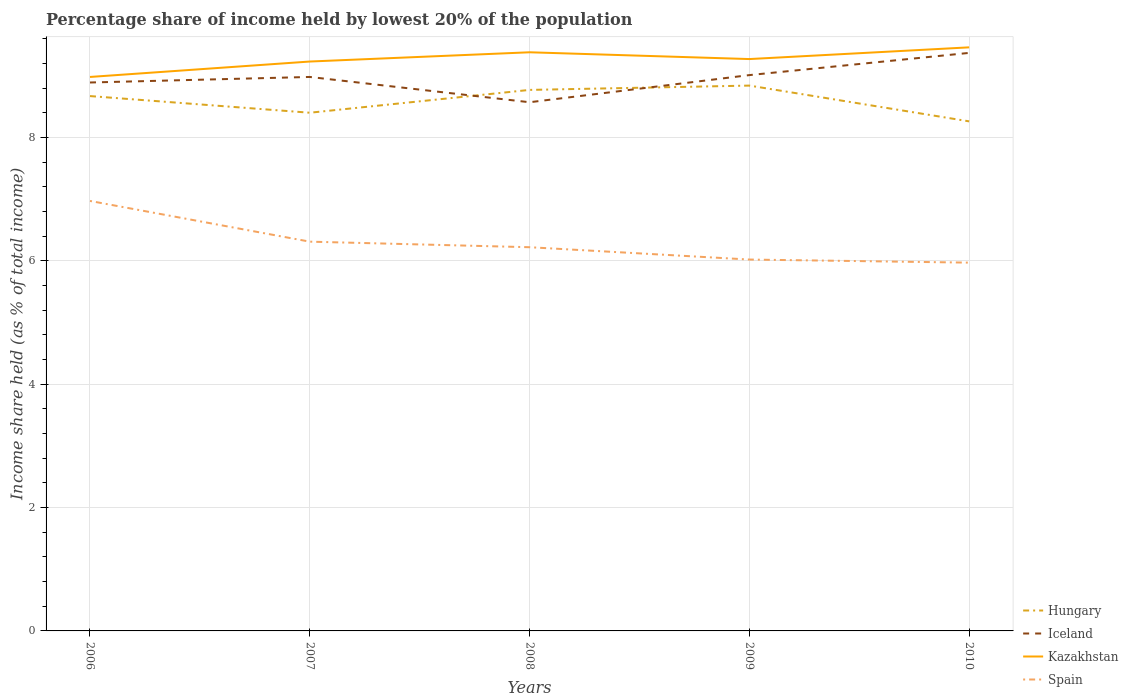Does the line corresponding to Iceland intersect with the line corresponding to Kazakhstan?
Keep it short and to the point. No. Is the number of lines equal to the number of legend labels?
Offer a very short reply. Yes. Across all years, what is the maximum percentage share of income held by lowest 20% of the population in Iceland?
Your answer should be compact. 8.57. What is the total percentage share of income held by lowest 20% of the population in Spain in the graph?
Make the answer very short. 0.66. What is the difference between the highest and the second highest percentage share of income held by lowest 20% of the population in Hungary?
Offer a very short reply. 0.58. What is the difference between the highest and the lowest percentage share of income held by lowest 20% of the population in Iceland?
Offer a terse response. 3. How many lines are there?
Make the answer very short. 4. How many years are there in the graph?
Your response must be concise. 5. Are the values on the major ticks of Y-axis written in scientific E-notation?
Ensure brevity in your answer.  No. Does the graph contain any zero values?
Ensure brevity in your answer.  No. Does the graph contain grids?
Your answer should be compact. Yes. How many legend labels are there?
Ensure brevity in your answer.  4. What is the title of the graph?
Give a very brief answer. Percentage share of income held by lowest 20% of the population. Does "Azerbaijan" appear as one of the legend labels in the graph?
Your answer should be compact. No. What is the label or title of the X-axis?
Your response must be concise. Years. What is the label or title of the Y-axis?
Offer a very short reply. Income share held (as % of total income). What is the Income share held (as % of total income) in Hungary in 2006?
Offer a very short reply. 8.67. What is the Income share held (as % of total income) of Iceland in 2006?
Ensure brevity in your answer.  8.89. What is the Income share held (as % of total income) in Kazakhstan in 2006?
Your response must be concise. 8.98. What is the Income share held (as % of total income) of Spain in 2006?
Offer a very short reply. 6.97. What is the Income share held (as % of total income) of Hungary in 2007?
Make the answer very short. 8.4. What is the Income share held (as % of total income) of Iceland in 2007?
Your answer should be compact. 8.98. What is the Income share held (as % of total income) in Kazakhstan in 2007?
Your response must be concise. 9.23. What is the Income share held (as % of total income) of Spain in 2007?
Give a very brief answer. 6.31. What is the Income share held (as % of total income) of Hungary in 2008?
Offer a very short reply. 8.77. What is the Income share held (as % of total income) of Iceland in 2008?
Offer a very short reply. 8.57. What is the Income share held (as % of total income) in Kazakhstan in 2008?
Your response must be concise. 9.38. What is the Income share held (as % of total income) in Spain in 2008?
Keep it short and to the point. 6.22. What is the Income share held (as % of total income) of Hungary in 2009?
Keep it short and to the point. 8.84. What is the Income share held (as % of total income) in Iceland in 2009?
Your answer should be very brief. 9.01. What is the Income share held (as % of total income) in Kazakhstan in 2009?
Keep it short and to the point. 9.27. What is the Income share held (as % of total income) of Spain in 2009?
Provide a short and direct response. 6.02. What is the Income share held (as % of total income) of Hungary in 2010?
Give a very brief answer. 8.26. What is the Income share held (as % of total income) of Iceland in 2010?
Offer a terse response. 9.37. What is the Income share held (as % of total income) in Kazakhstan in 2010?
Ensure brevity in your answer.  9.46. What is the Income share held (as % of total income) of Spain in 2010?
Provide a succinct answer. 5.97. Across all years, what is the maximum Income share held (as % of total income) in Hungary?
Offer a very short reply. 8.84. Across all years, what is the maximum Income share held (as % of total income) of Iceland?
Your answer should be very brief. 9.37. Across all years, what is the maximum Income share held (as % of total income) in Kazakhstan?
Make the answer very short. 9.46. Across all years, what is the maximum Income share held (as % of total income) in Spain?
Offer a very short reply. 6.97. Across all years, what is the minimum Income share held (as % of total income) in Hungary?
Ensure brevity in your answer.  8.26. Across all years, what is the minimum Income share held (as % of total income) in Iceland?
Your answer should be compact. 8.57. Across all years, what is the minimum Income share held (as % of total income) of Kazakhstan?
Provide a short and direct response. 8.98. Across all years, what is the minimum Income share held (as % of total income) in Spain?
Provide a succinct answer. 5.97. What is the total Income share held (as % of total income) of Hungary in the graph?
Make the answer very short. 42.94. What is the total Income share held (as % of total income) of Iceland in the graph?
Ensure brevity in your answer.  44.82. What is the total Income share held (as % of total income) of Kazakhstan in the graph?
Your answer should be very brief. 46.32. What is the total Income share held (as % of total income) in Spain in the graph?
Keep it short and to the point. 31.49. What is the difference between the Income share held (as % of total income) of Hungary in 2006 and that in 2007?
Make the answer very short. 0.27. What is the difference between the Income share held (as % of total income) in Iceland in 2006 and that in 2007?
Make the answer very short. -0.09. What is the difference between the Income share held (as % of total income) of Spain in 2006 and that in 2007?
Your response must be concise. 0.66. What is the difference between the Income share held (as % of total income) in Iceland in 2006 and that in 2008?
Your response must be concise. 0.32. What is the difference between the Income share held (as % of total income) of Kazakhstan in 2006 and that in 2008?
Offer a terse response. -0.4. What is the difference between the Income share held (as % of total income) of Hungary in 2006 and that in 2009?
Give a very brief answer. -0.17. What is the difference between the Income share held (as % of total income) of Iceland in 2006 and that in 2009?
Provide a succinct answer. -0.12. What is the difference between the Income share held (as % of total income) in Kazakhstan in 2006 and that in 2009?
Keep it short and to the point. -0.29. What is the difference between the Income share held (as % of total income) in Hungary in 2006 and that in 2010?
Keep it short and to the point. 0.41. What is the difference between the Income share held (as % of total income) of Iceland in 2006 and that in 2010?
Your answer should be very brief. -0.48. What is the difference between the Income share held (as % of total income) of Kazakhstan in 2006 and that in 2010?
Your response must be concise. -0.48. What is the difference between the Income share held (as % of total income) of Spain in 2006 and that in 2010?
Make the answer very short. 1. What is the difference between the Income share held (as % of total income) in Hungary in 2007 and that in 2008?
Your response must be concise. -0.37. What is the difference between the Income share held (as % of total income) of Iceland in 2007 and that in 2008?
Your response must be concise. 0.41. What is the difference between the Income share held (as % of total income) in Spain in 2007 and that in 2008?
Your answer should be very brief. 0.09. What is the difference between the Income share held (as % of total income) of Hungary in 2007 and that in 2009?
Keep it short and to the point. -0.44. What is the difference between the Income share held (as % of total income) of Iceland in 2007 and that in 2009?
Your answer should be very brief. -0.03. What is the difference between the Income share held (as % of total income) of Kazakhstan in 2007 and that in 2009?
Your answer should be compact. -0.04. What is the difference between the Income share held (as % of total income) in Spain in 2007 and that in 2009?
Provide a short and direct response. 0.29. What is the difference between the Income share held (as % of total income) of Hungary in 2007 and that in 2010?
Your response must be concise. 0.14. What is the difference between the Income share held (as % of total income) in Iceland in 2007 and that in 2010?
Provide a succinct answer. -0.39. What is the difference between the Income share held (as % of total income) in Kazakhstan in 2007 and that in 2010?
Your response must be concise. -0.23. What is the difference between the Income share held (as % of total income) in Spain in 2007 and that in 2010?
Offer a very short reply. 0.34. What is the difference between the Income share held (as % of total income) in Hungary in 2008 and that in 2009?
Make the answer very short. -0.07. What is the difference between the Income share held (as % of total income) in Iceland in 2008 and that in 2009?
Your answer should be compact. -0.44. What is the difference between the Income share held (as % of total income) in Kazakhstan in 2008 and that in 2009?
Offer a very short reply. 0.11. What is the difference between the Income share held (as % of total income) of Hungary in 2008 and that in 2010?
Your answer should be very brief. 0.51. What is the difference between the Income share held (as % of total income) in Iceland in 2008 and that in 2010?
Provide a short and direct response. -0.8. What is the difference between the Income share held (as % of total income) of Kazakhstan in 2008 and that in 2010?
Keep it short and to the point. -0.08. What is the difference between the Income share held (as % of total income) in Hungary in 2009 and that in 2010?
Make the answer very short. 0.58. What is the difference between the Income share held (as % of total income) in Iceland in 2009 and that in 2010?
Offer a very short reply. -0.36. What is the difference between the Income share held (as % of total income) in Kazakhstan in 2009 and that in 2010?
Your answer should be compact. -0.19. What is the difference between the Income share held (as % of total income) of Hungary in 2006 and the Income share held (as % of total income) of Iceland in 2007?
Provide a succinct answer. -0.31. What is the difference between the Income share held (as % of total income) of Hungary in 2006 and the Income share held (as % of total income) of Kazakhstan in 2007?
Your answer should be compact. -0.56. What is the difference between the Income share held (as % of total income) in Hungary in 2006 and the Income share held (as % of total income) in Spain in 2007?
Offer a terse response. 2.36. What is the difference between the Income share held (as % of total income) in Iceland in 2006 and the Income share held (as % of total income) in Kazakhstan in 2007?
Keep it short and to the point. -0.34. What is the difference between the Income share held (as % of total income) of Iceland in 2006 and the Income share held (as % of total income) of Spain in 2007?
Your answer should be compact. 2.58. What is the difference between the Income share held (as % of total income) of Kazakhstan in 2006 and the Income share held (as % of total income) of Spain in 2007?
Ensure brevity in your answer.  2.67. What is the difference between the Income share held (as % of total income) of Hungary in 2006 and the Income share held (as % of total income) of Iceland in 2008?
Your answer should be very brief. 0.1. What is the difference between the Income share held (as % of total income) of Hungary in 2006 and the Income share held (as % of total income) of Kazakhstan in 2008?
Your answer should be very brief. -0.71. What is the difference between the Income share held (as % of total income) of Hungary in 2006 and the Income share held (as % of total income) of Spain in 2008?
Offer a very short reply. 2.45. What is the difference between the Income share held (as % of total income) of Iceland in 2006 and the Income share held (as % of total income) of Kazakhstan in 2008?
Offer a very short reply. -0.49. What is the difference between the Income share held (as % of total income) of Iceland in 2006 and the Income share held (as % of total income) of Spain in 2008?
Your response must be concise. 2.67. What is the difference between the Income share held (as % of total income) of Kazakhstan in 2006 and the Income share held (as % of total income) of Spain in 2008?
Give a very brief answer. 2.76. What is the difference between the Income share held (as % of total income) of Hungary in 2006 and the Income share held (as % of total income) of Iceland in 2009?
Provide a succinct answer. -0.34. What is the difference between the Income share held (as % of total income) in Hungary in 2006 and the Income share held (as % of total income) in Kazakhstan in 2009?
Your answer should be compact. -0.6. What is the difference between the Income share held (as % of total income) of Hungary in 2006 and the Income share held (as % of total income) of Spain in 2009?
Provide a short and direct response. 2.65. What is the difference between the Income share held (as % of total income) of Iceland in 2006 and the Income share held (as % of total income) of Kazakhstan in 2009?
Provide a succinct answer. -0.38. What is the difference between the Income share held (as % of total income) in Iceland in 2006 and the Income share held (as % of total income) in Spain in 2009?
Your answer should be very brief. 2.87. What is the difference between the Income share held (as % of total income) of Kazakhstan in 2006 and the Income share held (as % of total income) of Spain in 2009?
Keep it short and to the point. 2.96. What is the difference between the Income share held (as % of total income) of Hungary in 2006 and the Income share held (as % of total income) of Kazakhstan in 2010?
Your answer should be very brief. -0.79. What is the difference between the Income share held (as % of total income) of Hungary in 2006 and the Income share held (as % of total income) of Spain in 2010?
Offer a very short reply. 2.7. What is the difference between the Income share held (as % of total income) of Iceland in 2006 and the Income share held (as % of total income) of Kazakhstan in 2010?
Make the answer very short. -0.57. What is the difference between the Income share held (as % of total income) of Iceland in 2006 and the Income share held (as % of total income) of Spain in 2010?
Offer a very short reply. 2.92. What is the difference between the Income share held (as % of total income) in Kazakhstan in 2006 and the Income share held (as % of total income) in Spain in 2010?
Ensure brevity in your answer.  3.01. What is the difference between the Income share held (as % of total income) of Hungary in 2007 and the Income share held (as % of total income) of Iceland in 2008?
Give a very brief answer. -0.17. What is the difference between the Income share held (as % of total income) in Hungary in 2007 and the Income share held (as % of total income) in Kazakhstan in 2008?
Your response must be concise. -0.98. What is the difference between the Income share held (as % of total income) in Hungary in 2007 and the Income share held (as % of total income) in Spain in 2008?
Offer a terse response. 2.18. What is the difference between the Income share held (as % of total income) of Iceland in 2007 and the Income share held (as % of total income) of Spain in 2008?
Your answer should be very brief. 2.76. What is the difference between the Income share held (as % of total income) in Kazakhstan in 2007 and the Income share held (as % of total income) in Spain in 2008?
Your answer should be very brief. 3.01. What is the difference between the Income share held (as % of total income) in Hungary in 2007 and the Income share held (as % of total income) in Iceland in 2009?
Keep it short and to the point. -0.61. What is the difference between the Income share held (as % of total income) of Hungary in 2007 and the Income share held (as % of total income) of Kazakhstan in 2009?
Offer a terse response. -0.87. What is the difference between the Income share held (as % of total income) of Hungary in 2007 and the Income share held (as % of total income) of Spain in 2009?
Ensure brevity in your answer.  2.38. What is the difference between the Income share held (as % of total income) of Iceland in 2007 and the Income share held (as % of total income) of Kazakhstan in 2009?
Ensure brevity in your answer.  -0.29. What is the difference between the Income share held (as % of total income) of Iceland in 2007 and the Income share held (as % of total income) of Spain in 2009?
Your answer should be very brief. 2.96. What is the difference between the Income share held (as % of total income) of Kazakhstan in 2007 and the Income share held (as % of total income) of Spain in 2009?
Your response must be concise. 3.21. What is the difference between the Income share held (as % of total income) of Hungary in 2007 and the Income share held (as % of total income) of Iceland in 2010?
Your response must be concise. -0.97. What is the difference between the Income share held (as % of total income) of Hungary in 2007 and the Income share held (as % of total income) of Kazakhstan in 2010?
Your answer should be compact. -1.06. What is the difference between the Income share held (as % of total income) of Hungary in 2007 and the Income share held (as % of total income) of Spain in 2010?
Give a very brief answer. 2.43. What is the difference between the Income share held (as % of total income) in Iceland in 2007 and the Income share held (as % of total income) in Kazakhstan in 2010?
Your response must be concise. -0.48. What is the difference between the Income share held (as % of total income) of Iceland in 2007 and the Income share held (as % of total income) of Spain in 2010?
Give a very brief answer. 3.01. What is the difference between the Income share held (as % of total income) in Kazakhstan in 2007 and the Income share held (as % of total income) in Spain in 2010?
Make the answer very short. 3.26. What is the difference between the Income share held (as % of total income) of Hungary in 2008 and the Income share held (as % of total income) of Iceland in 2009?
Offer a terse response. -0.24. What is the difference between the Income share held (as % of total income) in Hungary in 2008 and the Income share held (as % of total income) in Spain in 2009?
Give a very brief answer. 2.75. What is the difference between the Income share held (as % of total income) of Iceland in 2008 and the Income share held (as % of total income) of Spain in 2009?
Offer a very short reply. 2.55. What is the difference between the Income share held (as % of total income) in Kazakhstan in 2008 and the Income share held (as % of total income) in Spain in 2009?
Your answer should be very brief. 3.36. What is the difference between the Income share held (as % of total income) of Hungary in 2008 and the Income share held (as % of total income) of Iceland in 2010?
Make the answer very short. -0.6. What is the difference between the Income share held (as % of total income) of Hungary in 2008 and the Income share held (as % of total income) of Kazakhstan in 2010?
Give a very brief answer. -0.69. What is the difference between the Income share held (as % of total income) in Hungary in 2008 and the Income share held (as % of total income) in Spain in 2010?
Ensure brevity in your answer.  2.8. What is the difference between the Income share held (as % of total income) in Iceland in 2008 and the Income share held (as % of total income) in Kazakhstan in 2010?
Offer a terse response. -0.89. What is the difference between the Income share held (as % of total income) of Kazakhstan in 2008 and the Income share held (as % of total income) of Spain in 2010?
Ensure brevity in your answer.  3.41. What is the difference between the Income share held (as % of total income) of Hungary in 2009 and the Income share held (as % of total income) of Iceland in 2010?
Keep it short and to the point. -0.53. What is the difference between the Income share held (as % of total income) of Hungary in 2009 and the Income share held (as % of total income) of Kazakhstan in 2010?
Keep it short and to the point. -0.62. What is the difference between the Income share held (as % of total income) of Hungary in 2009 and the Income share held (as % of total income) of Spain in 2010?
Your response must be concise. 2.87. What is the difference between the Income share held (as % of total income) in Iceland in 2009 and the Income share held (as % of total income) in Kazakhstan in 2010?
Provide a short and direct response. -0.45. What is the difference between the Income share held (as % of total income) in Iceland in 2009 and the Income share held (as % of total income) in Spain in 2010?
Keep it short and to the point. 3.04. What is the average Income share held (as % of total income) in Hungary per year?
Your response must be concise. 8.59. What is the average Income share held (as % of total income) of Iceland per year?
Your response must be concise. 8.96. What is the average Income share held (as % of total income) of Kazakhstan per year?
Your answer should be very brief. 9.26. What is the average Income share held (as % of total income) of Spain per year?
Offer a very short reply. 6.3. In the year 2006, what is the difference between the Income share held (as % of total income) in Hungary and Income share held (as % of total income) in Iceland?
Provide a succinct answer. -0.22. In the year 2006, what is the difference between the Income share held (as % of total income) of Hungary and Income share held (as % of total income) of Kazakhstan?
Ensure brevity in your answer.  -0.31. In the year 2006, what is the difference between the Income share held (as % of total income) of Iceland and Income share held (as % of total income) of Kazakhstan?
Your answer should be very brief. -0.09. In the year 2006, what is the difference between the Income share held (as % of total income) in Iceland and Income share held (as % of total income) in Spain?
Your answer should be compact. 1.92. In the year 2006, what is the difference between the Income share held (as % of total income) in Kazakhstan and Income share held (as % of total income) in Spain?
Your answer should be compact. 2.01. In the year 2007, what is the difference between the Income share held (as % of total income) in Hungary and Income share held (as % of total income) in Iceland?
Keep it short and to the point. -0.58. In the year 2007, what is the difference between the Income share held (as % of total income) of Hungary and Income share held (as % of total income) of Kazakhstan?
Provide a short and direct response. -0.83. In the year 2007, what is the difference between the Income share held (as % of total income) of Hungary and Income share held (as % of total income) of Spain?
Offer a very short reply. 2.09. In the year 2007, what is the difference between the Income share held (as % of total income) in Iceland and Income share held (as % of total income) in Spain?
Make the answer very short. 2.67. In the year 2007, what is the difference between the Income share held (as % of total income) of Kazakhstan and Income share held (as % of total income) of Spain?
Offer a terse response. 2.92. In the year 2008, what is the difference between the Income share held (as % of total income) in Hungary and Income share held (as % of total income) in Iceland?
Provide a short and direct response. 0.2. In the year 2008, what is the difference between the Income share held (as % of total income) of Hungary and Income share held (as % of total income) of Kazakhstan?
Your answer should be very brief. -0.61. In the year 2008, what is the difference between the Income share held (as % of total income) in Hungary and Income share held (as % of total income) in Spain?
Your response must be concise. 2.55. In the year 2008, what is the difference between the Income share held (as % of total income) of Iceland and Income share held (as % of total income) of Kazakhstan?
Ensure brevity in your answer.  -0.81. In the year 2008, what is the difference between the Income share held (as % of total income) of Iceland and Income share held (as % of total income) of Spain?
Keep it short and to the point. 2.35. In the year 2008, what is the difference between the Income share held (as % of total income) in Kazakhstan and Income share held (as % of total income) in Spain?
Offer a very short reply. 3.16. In the year 2009, what is the difference between the Income share held (as % of total income) in Hungary and Income share held (as % of total income) in Iceland?
Give a very brief answer. -0.17. In the year 2009, what is the difference between the Income share held (as % of total income) of Hungary and Income share held (as % of total income) of Kazakhstan?
Give a very brief answer. -0.43. In the year 2009, what is the difference between the Income share held (as % of total income) in Hungary and Income share held (as % of total income) in Spain?
Give a very brief answer. 2.82. In the year 2009, what is the difference between the Income share held (as % of total income) in Iceland and Income share held (as % of total income) in Kazakhstan?
Offer a very short reply. -0.26. In the year 2009, what is the difference between the Income share held (as % of total income) of Iceland and Income share held (as % of total income) of Spain?
Your answer should be compact. 2.99. In the year 2010, what is the difference between the Income share held (as % of total income) of Hungary and Income share held (as % of total income) of Iceland?
Ensure brevity in your answer.  -1.11. In the year 2010, what is the difference between the Income share held (as % of total income) of Hungary and Income share held (as % of total income) of Kazakhstan?
Ensure brevity in your answer.  -1.2. In the year 2010, what is the difference between the Income share held (as % of total income) of Hungary and Income share held (as % of total income) of Spain?
Your response must be concise. 2.29. In the year 2010, what is the difference between the Income share held (as % of total income) in Iceland and Income share held (as % of total income) in Kazakhstan?
Your response must be concise. -0.09. In the year 2010, what is the difference between the Income share held (as % of total income) of Iceland and Income share held (as % of total income) of Spain?
Give a very brief answer. 3.4. In the year 2010, what is the difference between the Income share held (as % of total income) of Kazakhstan and Income share held (as % of total income) of Spain?
Make the answer very short. 3.49. What is the ratio of the Income share held (as % of total income) of Hungary in 2006 to that in 2007?
Your response must be concise. 1.03. What is the ratio of the Income share held (as % of total income) in Iceland in 2006 to that in 2007?
Your answer should be compact. 0.99. What is the ratio of the Income share held (as % of total income) of Kazakhstan in 2006 to that in 2007?
Give a very brief answer. 0.97. What is the ratio of the Income share held (as % of total income) of Spain in 2006 to that in 2007?
Provide a succinct answer. 1.1. What is the ratio of the Income share held (as % of total income) in Iceland in 2006 to that in 2008?
Your response must be concise. 1.04. What is the ratio of the Income share held (as % of total income) of Kazakhstan in 2006 to that in 2008?
Provide a short and direct response. 0.96. What is the ratio of the Income share held (as % of total income) of Spain in 2006 to that in 2008?
Your response must be concise. 1.12. What is the ratio of the Income share held (as % of total income) of Hungary in 2006 to that in 2009?
Provide a short and direct response. 0.98. What is the ratio of the Income share held (as % of total income) in Iceland in 2006 to that in 2009?
Offer a very short reply. 0.99. What is the ratio of the Income share held (as % of total income) in Kazakhstan in 2006 to that in 2009?
Provide a succinct answer. 0.97. What is the ratio of the Income share held (as % of total income) in Spain in 2006 to that in 2009?
Your answer should be compact. 1.16. What is the ratio of the Income share held (as % of total income) of Hungary in 2006 to that in 2010?
Offer a terse response. 1.05. What is the ratio of the Income share held (as % of total income) in Iceland in 2006 to that in 2010?
Provide a short and direct response. 0.95. What is the ratio of the Income share held (as % of total income) of Kazakhstan in 2006 to that in 2010?
Offer a terse response. 0.95. What is the ratio of the Income share held (as % of total income) of Spain in 2006 to that in 2010?
Your answer should be compact. 1.17. What is the ratio of the Income share held (as % of total income) of Hungary in 2007 to that in 2008?
Keep it short and to the point. 0.96. What is the ratio of the Income share held (as % of total income) in Iceland in 2007 to that in 2008?
Provide a succinct answer. 1.05. What is the ratio of the Income share held (as % of total income) in Spain in 2007 to that in 2008?
Provide a short and direct response. 1.01. What is the ratio of the Income share held (as % of total income) in Hungary in 2007 to that in 2009?
Your answer should be compact. 0.95. What is the ratio of the Income share held (as % of total income) in Iceland in 2007 to that in 2009?
Ensure brevity in your answer.  1. What is the ratio of the Income share held (as % of total income) of Kazakhstan in 2007 to that in 2009?
Keep it short and to the point. 1. What is the ratio of the Income share held (as % of total income) of Spain in 2007 to that in 2009?
Your answer should be very brief. 1.05. What is the ratio of the Income share held (as % of total income) in Hungary in 2007 to that in 2010?
Your answer should be very brief. 1.02. What is the ratio of the Income share held (as % of total income) of Iceland in 2007 to that in 2010?
Ensure brevity in your answer.  0.96. What is the ratio of the Income share held (as % of total income) in Kazakhstan in 2007 to that in 2010?
Make the answer very short. 0.98. What is the ratio of the Income share held (as % of total income) in Spain in 2007 to that in 2010?
Your answer should be very brief. 1.06. What is the ratio of the Income share held (as % of total income) in Hungary in 2008 to that in 2009?
Offer a terse response. 0.99. What is the ratio of the Income share held (as % of total income) in Iceland in 2008 to that in 2009?
Give a very brief answer. 0.95. What is the ratio of the Income share held (as % of total income) in Kazakhstan in 2008 to that in 2009?
Keep it short and to the point. 1.01. What is the ratio of the Income share held (as % of total income) of Spain in 2008 to that in 2009?
Your response must be concise. 1.03. What is the ratio of the Income share held (as % of total income) in Hungary in 2008 to that in 2010?
Offer a very short reply. 1.06. What is the ratio of the Income share held (as % of total income) in Iceland in 2008 to that in 2010?
Your response must be concise. 0.91. What is the ratio of the Income share held (as % of total income) of Spain in 2008 to that in 2010?
Provide a short and direct response. 1.04. What is the ratio of the Income share held (as % of total income) of Hungary in 2009 to that in 2010?
Ensure brevity in your answer.  1.07. What is the ratio of the Income share held (as % of total income) of Iceland in 2009 to that in 2010?
Your answer should be very brief. 0.96. What is the ratio of the Income share held (as % of total income) of Kazakhstan in 2009 to that in 2010?
Provide a short and direct response. 0.98. What is the ratio of the Income share held (as % of total income) of Spain in 2009 to that in 2010?
Your answer should be very brief. 1.01. What is the difference between the highest and the second highest Income share held (as % of total income) in Hungary?
Your response must be concise. 0.07. What is the difference between the highest and the second highest Income share held (as % of total income) of Iceland?
Offer a very short reply. 0.36. What is the difference between the highest and the second highest Income share held (as % of total income) of Kazakhstan?
Provide a short and direct response. 0.08. What is the difference between the highest and the second highest Income share held (as % of total income) of Spain?
Provide a succinct answer. 0.66. What is the difference between the highest and the lowest Income share held (as % of total income) of Hungary?
Offer a very short reply. 0.58. What is the difference between the highest and the lowest Income share held (as % of total income) in Kazakhstan?
Your response must be concise. 0.48. What is the difference between the highest and the lowest Income share held (as % of total income) in Spain?
Provide a succinct answer. 1. 